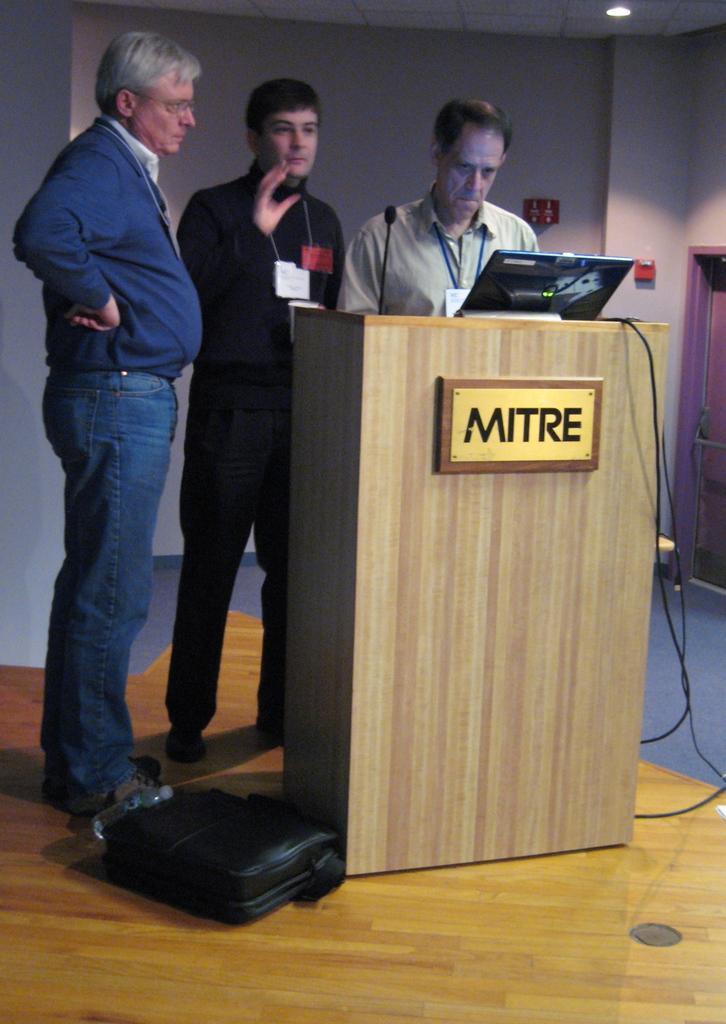Describe this image in one or two sentences. In this picture we can see there are three men standing on the floor. On the floor there is a bottle and a bag. In front of the men, there is a podium. On the podium, there is a microphone, laptop and cables and there is a board attached to the podium. Behind the men, there are some objects on the wall. At the top right corner of the image, there is a ceiling light. 